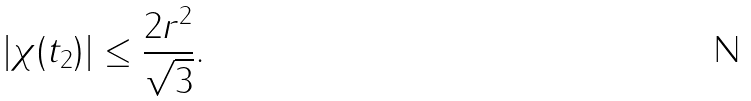<formula> <loc_0><loc_0><loc_500><loc_500>| \chi ( t _ { 2 } ) | \leq \frac { 2 r ^ { 2 } } { \sqrt { 3 } } .</formula> 